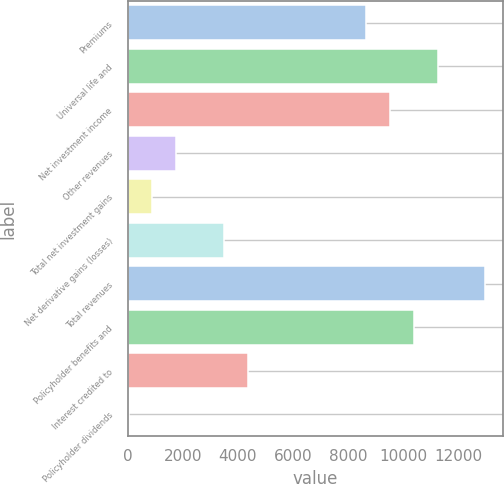Convert chart to OTSL. <chart><loc_0><loc_0><loc_500><loc_500><bar_chart><fcel>Premiums<fcel>Universal life and<fcel>Net investment income<fcel>Other revenues<fcel>Total net investment gains<fcel>Net derivative gains (losses)<fcel>Total revenues<fcel>Policyholder benefits and<fcel>Interest credited to<fcel>Policyholder dividends<nl><fcel>8660<fcel>11248.4<fcel>9522.8<fcel>1757.6<fcel>894.8<fcel>3483.2<fcel>12974<fcel>10385.6<fcel>4346<fcel>32<nl></chart> 